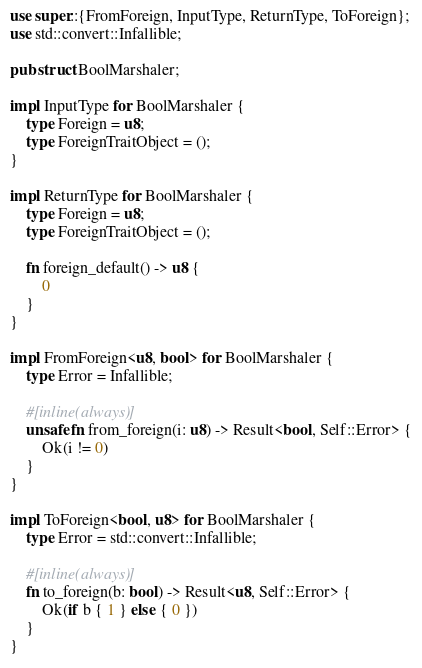Convert code to text. <code><loc_0><loc_0><loc_500><loc_500><_Rust_>use super::{FromForeign, InputType, ReturnType, ToForeign};
use std::convert::Infallible;

pub struct BoolMarshaler;

impl InputType for BoolMarshaler {
    type Foreign = u8;
    type ForeignTraitObject = ();
}

impl ReturnType for BoolMarshaler {
    type Foreign = u8;
    type ForeignTraitObject = ();

    fn foreign_default() -> u8 {
        0
    }
}

impl FromForeign<u8, bool> for BoolMarshaler {
    type Error = Infallible;

    #[inline(always)]
    unsafe fn from_foreign(i: u8) -> Result<bool, Self::Error> {
        Ok(i != 0)
    }
}

impl ToForeign<bool, u8> for BoolMarshaler {
    type Error = std::convert::Infallible;

    #[inline(always)]
    fn to_foreign(b: bool) -> Result<u8, Self::Error> {
        Ok(if b { 1 } else { 0 })
    }
}
</code> 